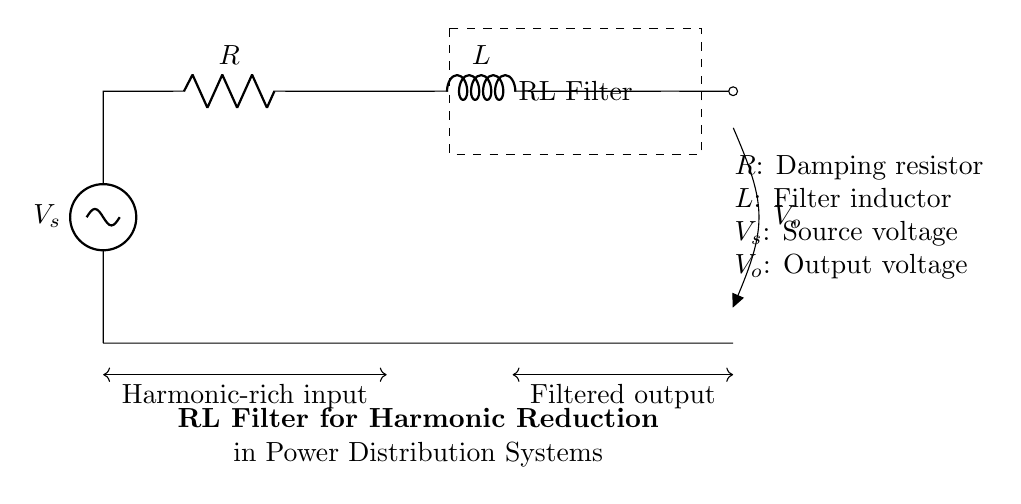What type of filter is represented in the circuit? The circuit represents an RL filter, which consists of a resistor and an inductor designed to process signals by attenuating certain frequency components.
Answer: RL filter What are the components used in this circuit? The circuit includes a resistor and an inductor as its primary components. The resistor is typically used for damping, while the inductor is used for filtering.
Answer: Resistor and inductor What is the role of the resistor in this RL filter? The resistor serves to provide damping, which helps to stabilize the circuit and can reduce oscillations, making the filter more effective in certain frequency ranges.
Answer: Damping What happens to a harmonic-rich input signal in this circuit? The input signal, which contains multiple frequencies (harmonics), will experience attenuation of unwanted frequencies, leading to a cleaner filtered output.
Answer: It gets filtered What is the expected output voltage when the input is harmonic-rich? The output voltage will be less than the source voltage due to the filter's attenuation of specific frequency components, primarily harmonics.
Answer: Less than source voltage How does the inductor affect the performance of this RL filter? The inductor primarily reacts to changes in current and opposes rapid changes, allowing it to attenuate high-frequency components of the input signal effectively.
Answer: Attenuates high frequencies What is indicated by the voltage labeled as V_o in the circuit? The voltage labeled V_o indicates the filtered output voltage, which is the voltage across the load after the harmonic-rich input has been processed through the filter.
Answer: Filtered output voltage 